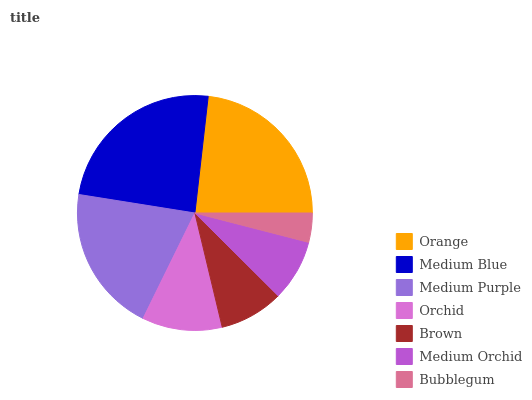Is Bubblegum the minimum?
Answer yes or no. Yes. Is Medium Blue the maximum?
Answer yes or no. Yes. Is Medium Purple the minimum?
Answer yes or no. No. Is Medium Purple the maximum?
Answer yes or no. No. Is Medium Blue greater than Medium Purple?
Answer yes or no. Yes. Is Medium Purple less than Medium Blue?
Answer yes or no. Yes. Is Medium Purple greater than Medium Blue?
Answer yes or no. No. Is Medium Blue less than Medium Purple?
Answer yes or no. No. Is Orchid the high median?
Answer yes or no. Yes. Is Orchid the low median?
Answer yes or no. Yes. Is Bubblegum the high median?
Answer yes or no. No. Is Medium Blue the low median?
Answer yes or no. No. 